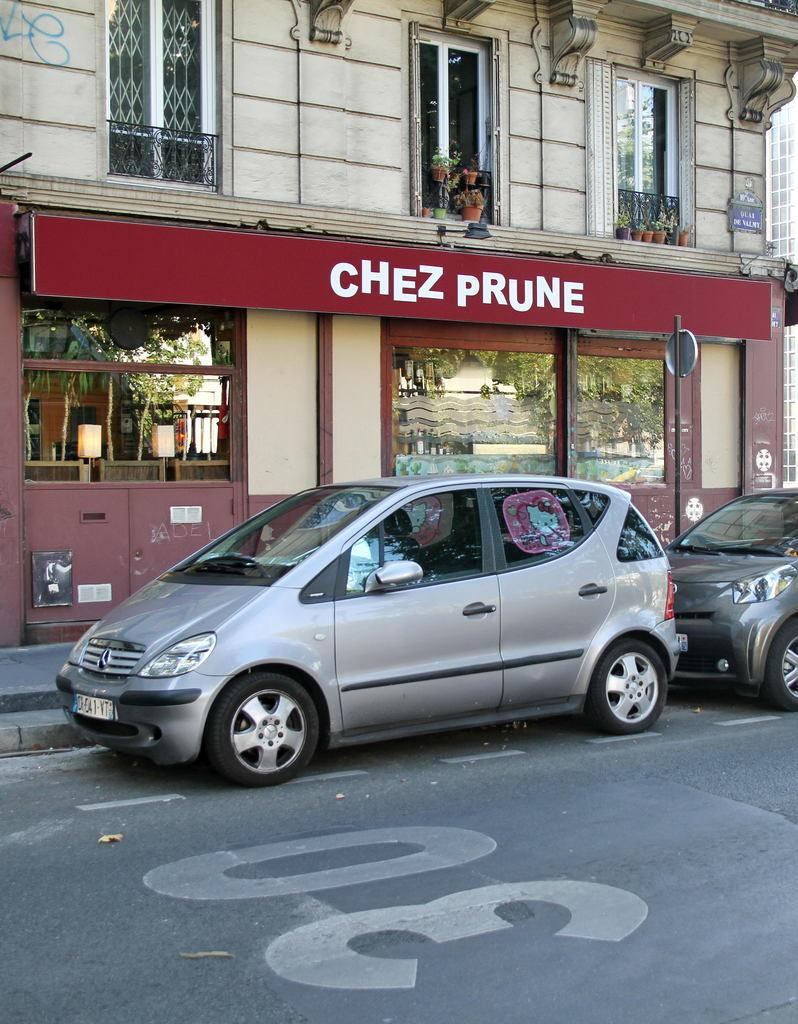What type of structures can be seen in the image? There are buildings in the image. What feature can be found on the buildings in the image? There are windows in the image. What objects are present near the buildings? There are pots and plants in the image. How might someone enter or exit the buildings? There is a door in the image. What type of vehicles are visible in the image? There are cars in the image. What type of pie is being discussed by the rat in the image? There is no rat or pie present in the image. What flavor of pie might the rat be interested in? Since there is no rat or pie in the image, it is impossible to determine the flavor of pie that might be discussed. 